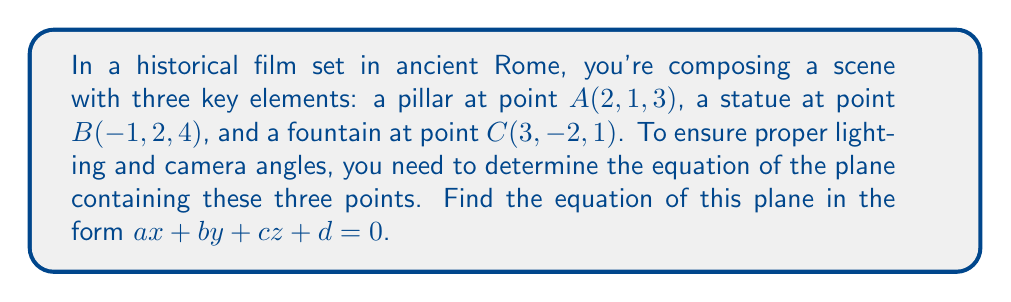Teach me how to tackle this problem. To find the equation of a plane containing three points, we can follow these steps:

1) First, we need to find two vectors on the plane. We can do this by subtracting the coordinates of two points from the third:

   $\vec{AB} = B - A = (-1-2, 2-1, 4-3) = (-3, 1, 1)$
   $\vec{AC} = C - A = (3-2, -2-1, 1-3) = (1, -3, -2)$

2) The normal vector to the plane will be the cross product of these two vectors:

   $\vec{n} = \vec{AB} \times \vec{AC} = \begin{vmatrix} 
   i & j & k \\
   -3 & 1 & 1 \\
   1 & -3 & -2
   \end{vmatrix}$

   $= (1(-2) - 1(-3))i - (-3(-2) - 1(1))j + (-3(-3) - 1(1))k$
   $= -2+3)i - (-6-1)j + (9-1)k$
   $= i + 7j + 8k$

3) So, the normal vector is $\vec{n} = (1, 7, 8)$. The equation of the plane will be of the form:

   $1(x-x_0) + 7(y-y_0) + 8(z-z_0) = 0$

   where $(x_0, y_0, z_0)$ is any point on the plane. We can use point $A(2, 1, 3)$.

4) Substituting:

   $1(x-2) + 7(y-1) + 8(z-3) = 0$

5) Expanding:

   $x - 2 + 7y - 7 + 8z - 24 = 0$
   $x + 7y + 8z - 33 = 0$

This is the equation of the plane in the form $ax + by + cz + d = 0$.
Answer: $x + 7y + 8z - 33 = 0$ 